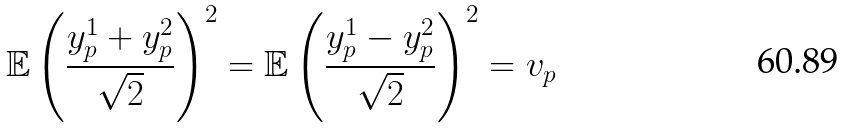Convert formula to latex. <formula><loc_0><loc_0><loc_500><loc_500>& \mathbb { E } \left ( \frac { y _ { p } ^ { 1 } + y _ { p } ^ { 2 } } { \sqrt { 2 } } \right ) ^ { 2 } = \mathbb { E } \left ( \frac { y _ { p } ^ { 1 } - y _ { p } ^ { 2 } } { \sqrt { 2 } } \right ) ^ { 2 } = v _ { p }</formula> 